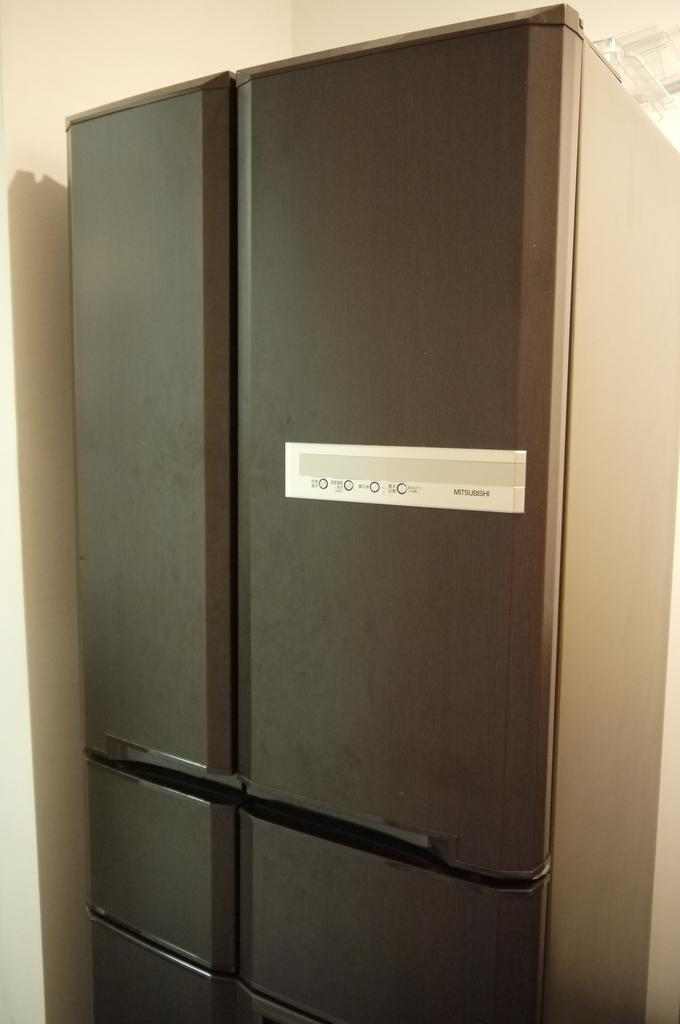<image>
Give a short and clear explanation of the subsequent image. the exterior of a mitsubishi fridge in a lit room 